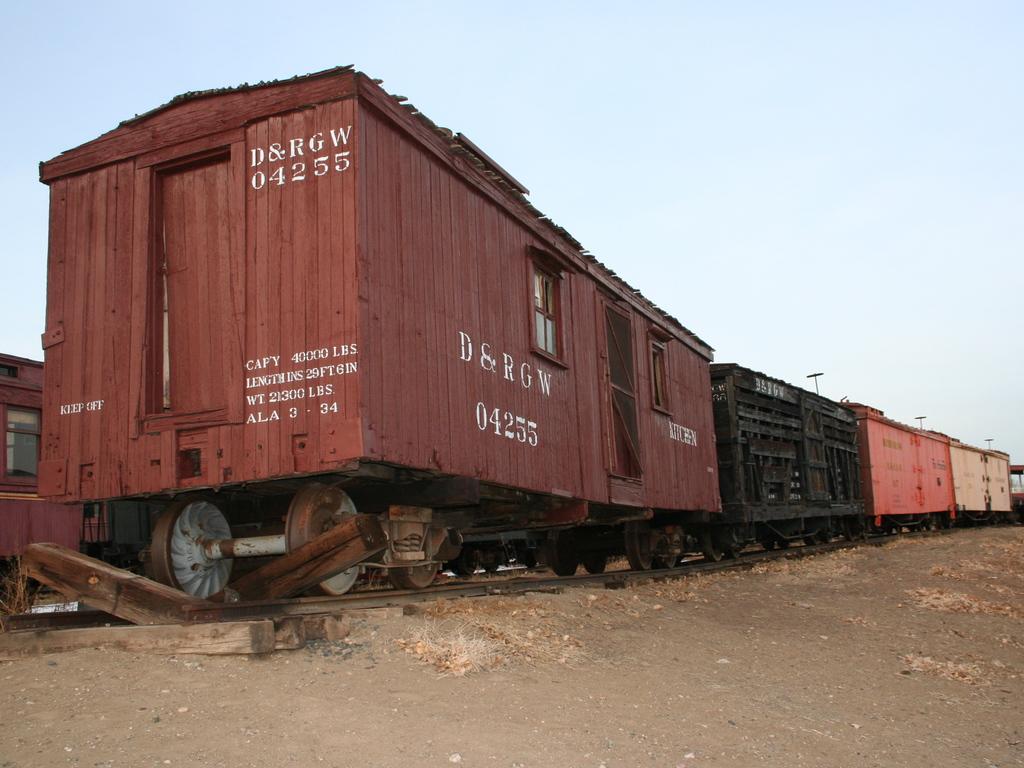What is the train car number?
Your answer should be very brief. 04255. What is the company name?
Ensure brevity in your answer.  D&rgw. 